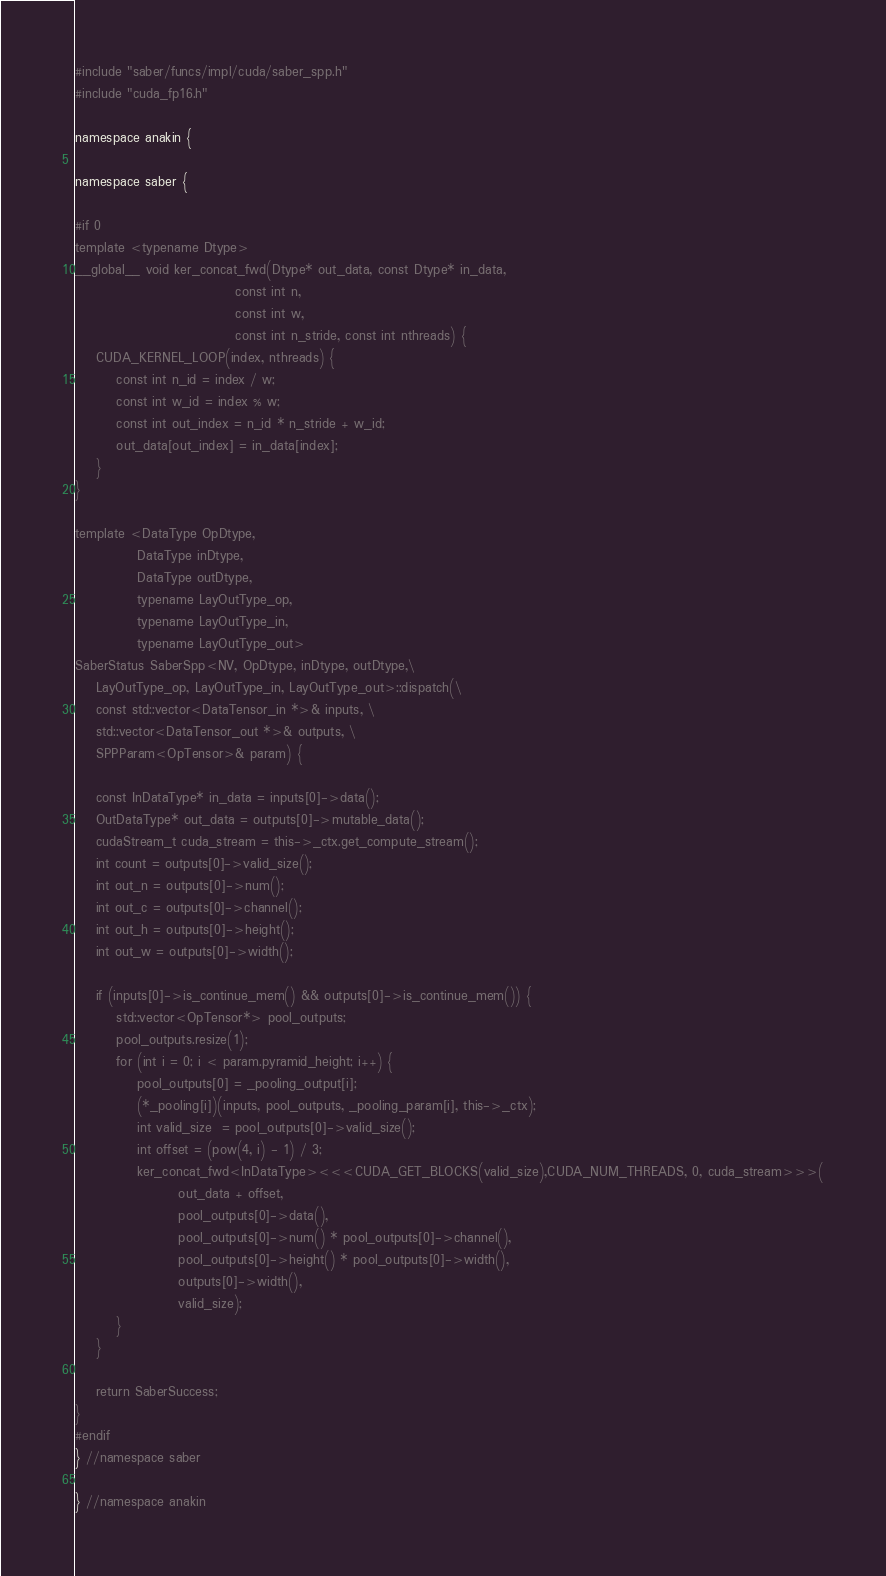<code> <loc_0><loc_0><loc_500><loc_500><_Cuda_>#include "saber/funcs/impl/cuda/saber_spp.h"
#include "cuda_fp16.h"

namespace anakin {

namespace saber {

#if 0    
template <typename Dtype>
__global__ void ker_concat_fwd(Dtype* out_data, const Dtype* in_data,
                               const int n,
                               const int w,
                               const int n_stride, const int nthreads) {
    CUDA_KERNEL_LOOP(index, nthreads) {
        const int n_id = index / w;
        const int w_id = index % w;
        const int out_index = n_id * n_stride + w_id;
        out_data[out_index] = in_data[index];
    }
}

template <DataType OpDtype,
            DataType inDtype,
            DataType outDtype,
            typename LayOutType_op,
            typename LayOutType_in,
            typename LayOutType_out>
SaberStatus SaberSpp<NV, OpDtype, inDtype, outDtype,\
    LayOutType_op, LayOutType_in, LayOutType_out>::dispatch(\
    const std::vector<DataTensor_in *>& inputs, \
    std::vector<DataTensor_out *>& outputs, \
    SPPParam<OpTensor>& param) {

    const InDataType* in_data = inputs[0]->data();
    OutDataType* out_data = outputs[0]->mutable_data();
    cudaStream_t cuda_stream = this->_ctx.get_compute_stream();
    int count = outputs[0]->valid_size();
    int out_n = outputs[0]->num();
    int out_c = outputs[0]->channel();
    int out_h = outputs[0]->height();
    int out_w = outputs[0]->width();

    if (inputs[0]->is_continue_mem() && outputs[0]->is_continue_mem()) {
        std::vector<OpTensor*> pool_outputs;
        pool_outputs.resize(1);
        for (int i = 0; i < param.pyramid_height; i++) {
            pool_outputs[0] = _pooling_output[i];
            (*_pooling[i])(inputs, pool_outputs, _pooling_param[i], this->_ctx);
            int valid_size  = pool_outputs[0]->valid_size();
            int offset = (pow(4, i) - 1) / 3;
            ker_concat_fwd<InDataType><<<CUDA_GET_BLOCKS(valid_size),CUDA_NUM_THREADS, 0, cuda_stream>>>(
                    out_data + offset, 
                    pool_outputs[0]->data(), 
                    pool_outputs[0]->num() * pool_outputs[0]->channel(), 
                    pool_outputs[0]->height() * pool_outputs[0]->width(), 
                    outputs[0]->width(), 
                    valid_size);
        }
    }

    return SaberSuccess;
}
#endif
} //namespace saber

} //namespace anakin
</code> 